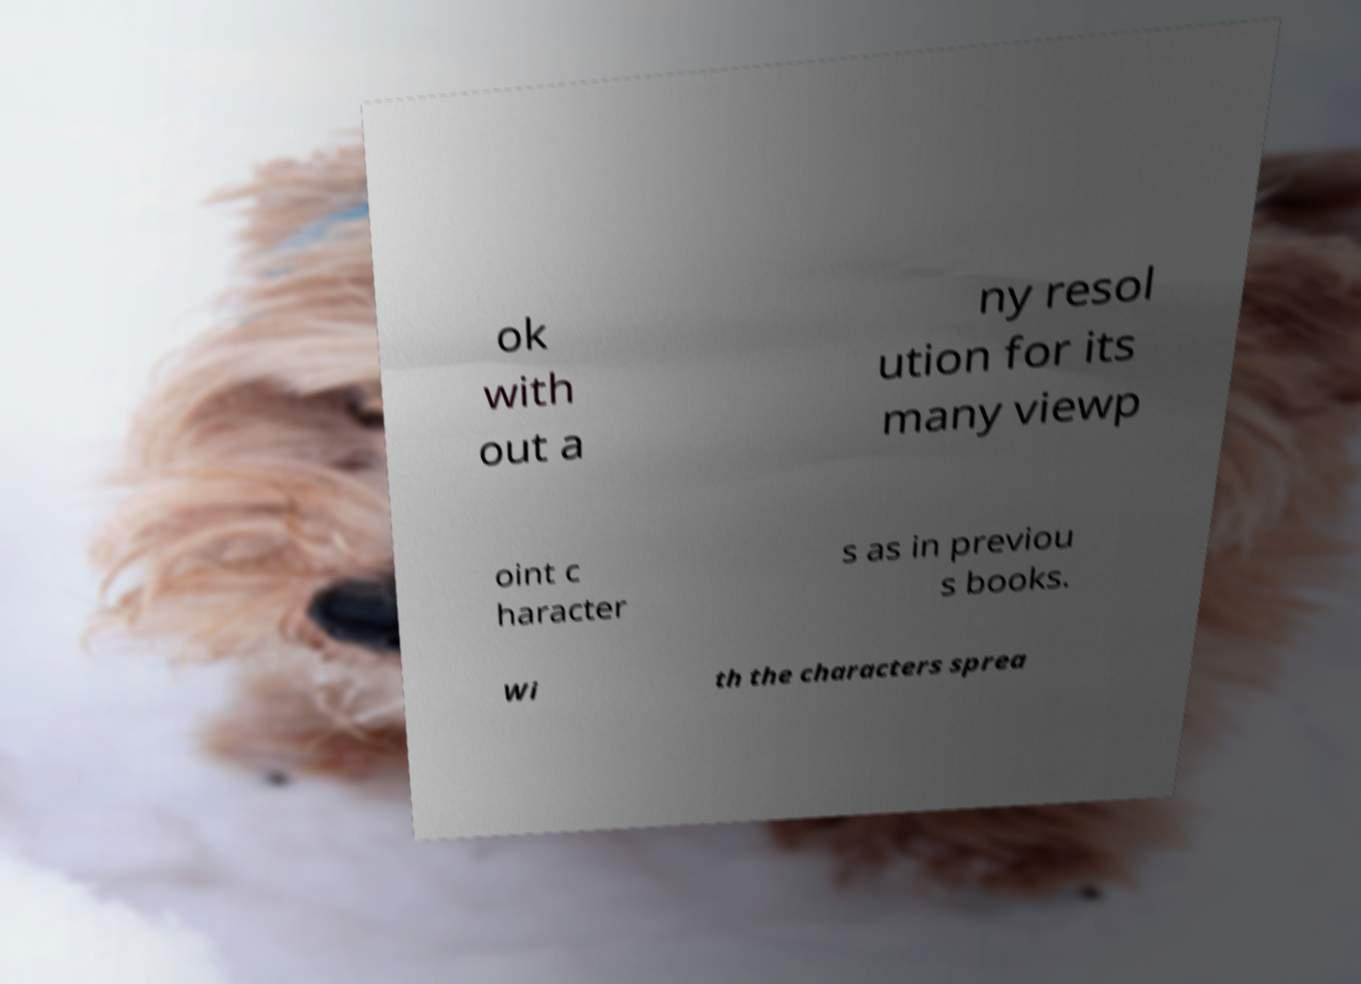Could you assist in decoding the text presented in this image and type it out clearly? ok with out a ny resol ution for its many viewp oint c haracter s as in previou s books. Wi th the characters sprea 